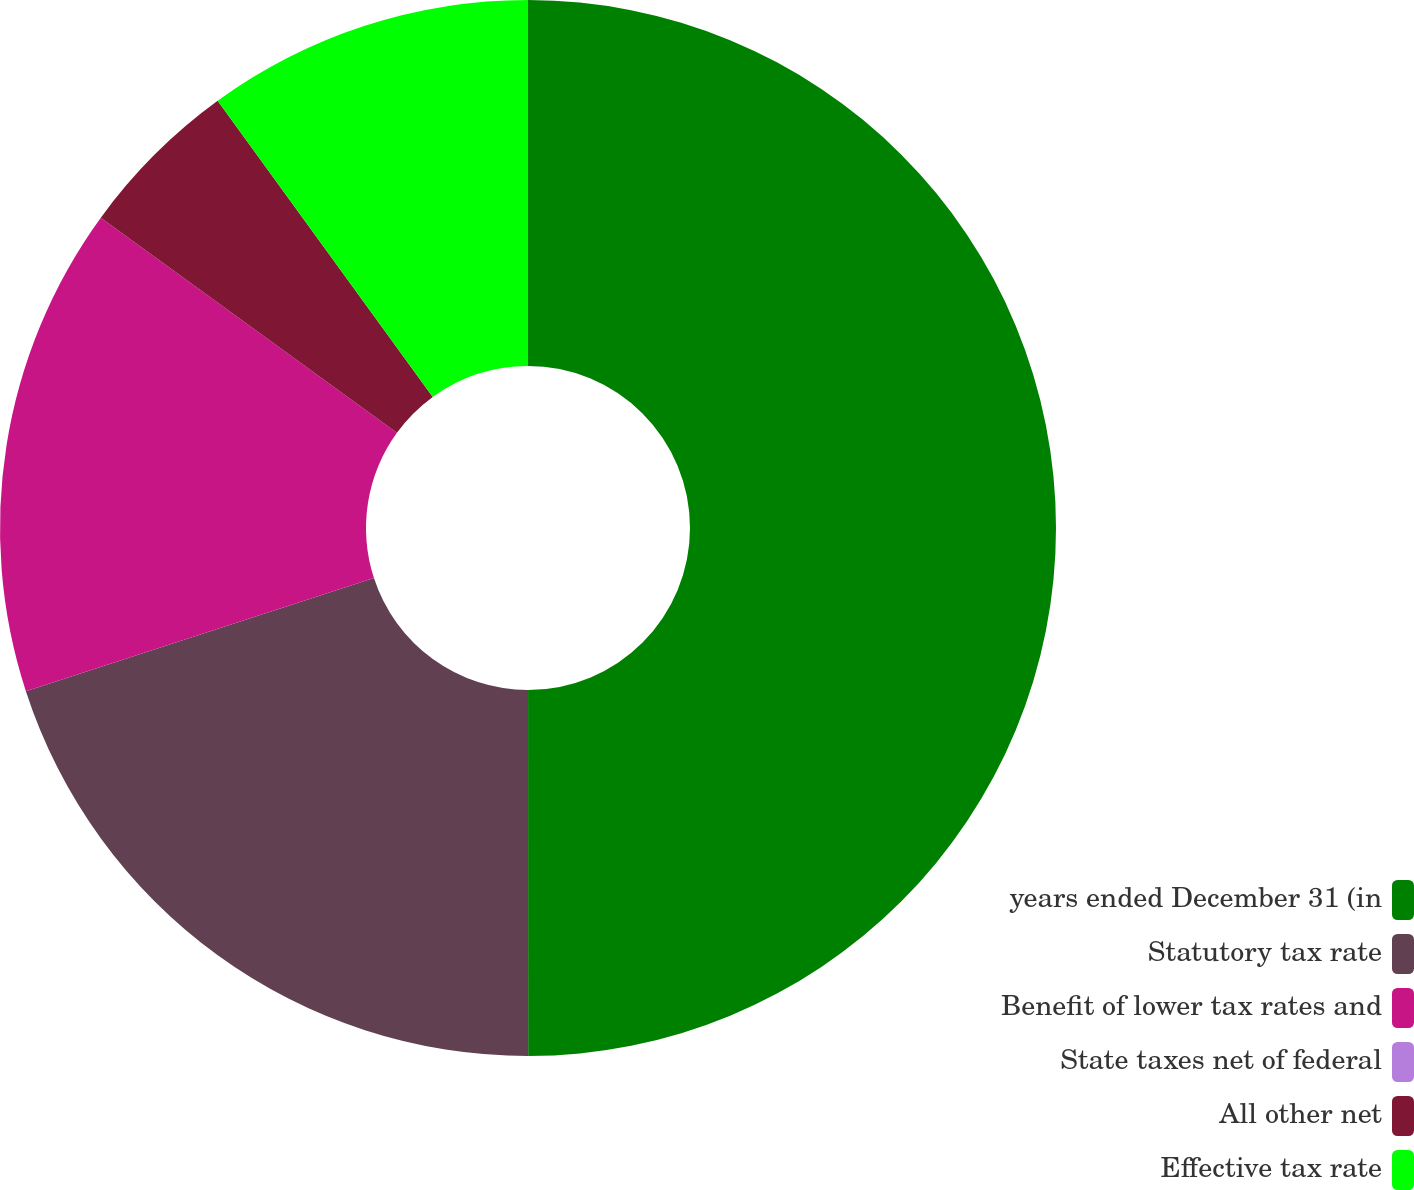Convert chart. <chart><loc_0><loc_0><loc_500><loc_500><pie_chart><fcel>years ended December 31 (in<fcel>Statutory tax rate<fcel>Benefit of lower tax rates and<fcel>State taxes net of federal<fcel>All other net<fcel>Effective tax rate<nl><fcel>49.99%<fcel>20.0%<fcel>15.0%<fcel>0.0%<fcel>5.0%<fcel>10.0%<nl></chart> 